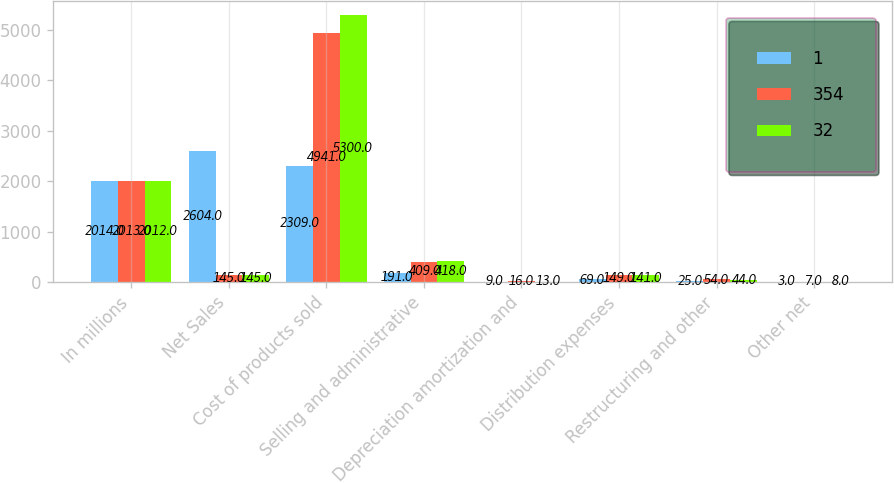Convert chart to OTSL. <chart><loc_0><loc_0><loc_500><loc_500><stacked_bar_chart><ecel><fcel>In millions<fcel>Net Sales<fcel>Cost of products sold<fcel>Selling and administrative<fcel>Depreciation amortization and<fcel>Distribution expenses<fcel>Restructuring and other<fcel>Other net<nl><fcel>1<fcel>2014<fcel>2604<fcel>2309<fcel>191<fcel>9<fcel>69<fcel>25<fcel>3<nl><fcel>354<fcel>2013<fcel>145<fcel>4941<fcel>409<fcel>16<fcel>149<fcel>54<fcel>7<nl><fcel>32<fcel>2012<fcel>145<fcel>5300<fcel>418<fcel>13<fcel>141<fcel>44<fcel>8<nl></chart> 